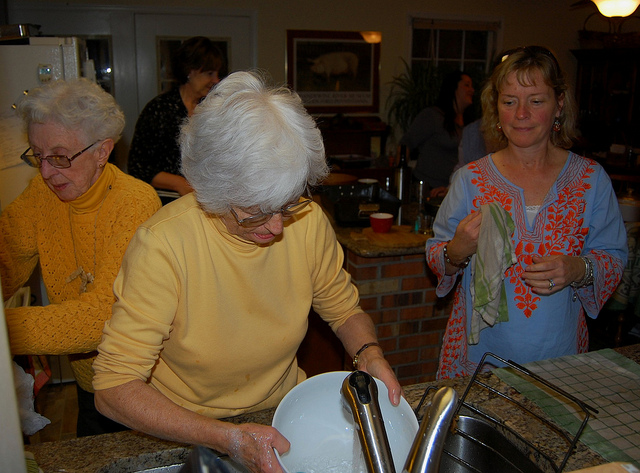<image>What color is the photo? It is ambiguous what the color of the photo is. It could be yellow or multiple colors. What is in the oven? I don't know what is in the oven. It can be pizza or nothing. What color is the photo? I am not sure what color the photo is. It can be seen as yellow, blue, and red. What is in the oven? It can be seen in the oven that there is food, possibly pizza. 